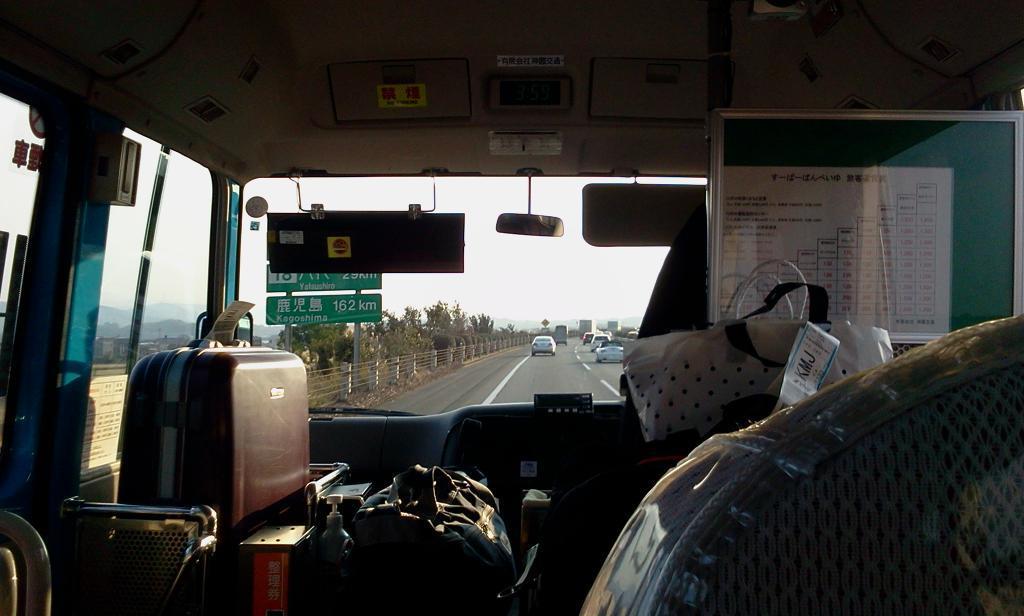Could you give a brief overview of what you see in this image? In this image, there is a inside view of the vehicle contains bags and mirror. There are some cars on the road. There is a sign board and fencing beside the road. There are some trees beside the road. There is a sky at the center of this image. 